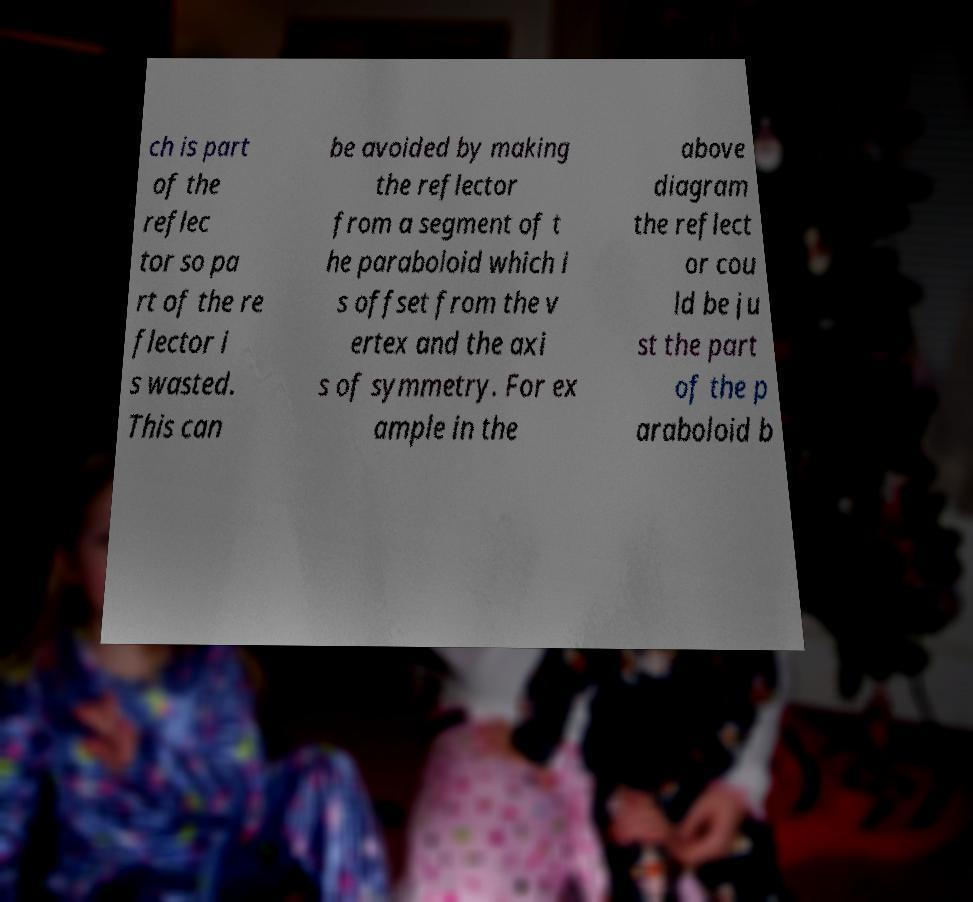Can you read and provide the text displayed in the image?This photo seems to have some interesting text. Can you extract and type it out for me? ch is part of the reflec tor so pa rt of the re flector i s wasted. This can be avoided by making the reflector from a segment of t he paraboloid which i s offset from the v ertex and the axi s of symmetry. For ex ample in the above diagram the reflect or cou ld be ju st the part of the p araboloid b 